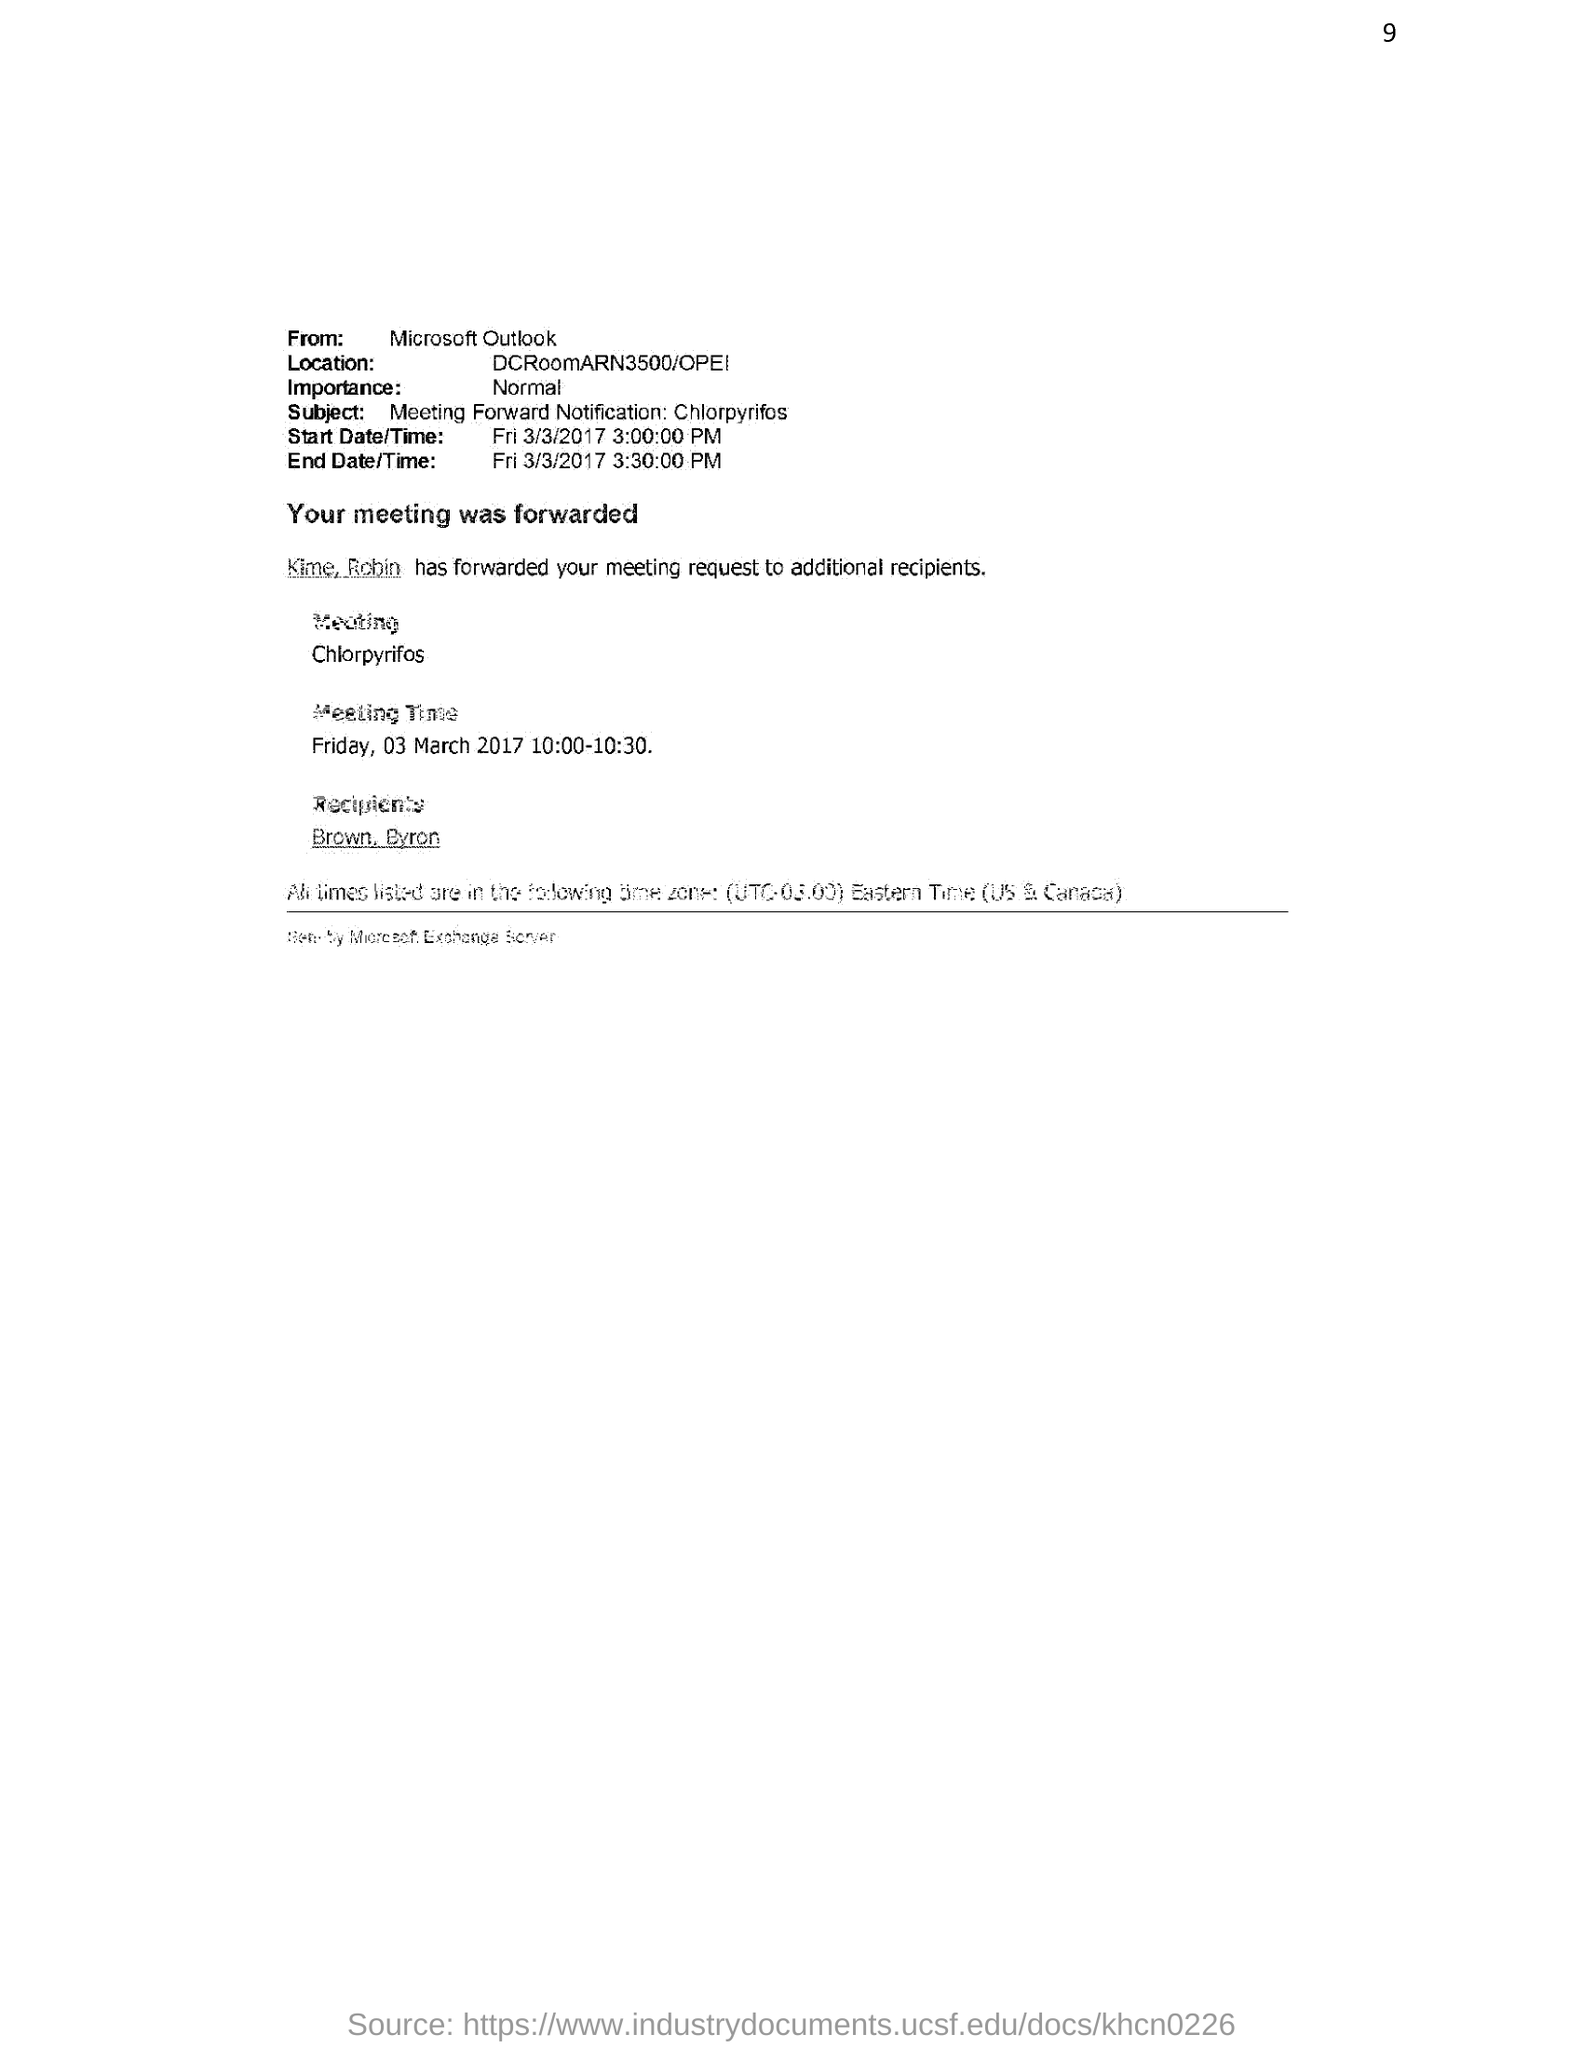Who is the sender of the email?
Provide a succinct answer. Microsoft Outlook. What is the importance of this email?
Your answer should be very brief. Normal. What is the start date/time mentioned in the email?
Give a very brief answer. Fri 3/3/2017 3:00:00 PM. What is the End date/time mentioned in the email?
Make the answer very short. Fri 3/3/2017 3:30:00 PM. What is the meeting time given in the email?
Your answer should be very brief. Friday, 03 March 2017 10:00-10:30. What is the subject of this email?
Offer a very short reply. Meeting Forward Notification: Chlorpyrifos. Who is the recipient of the meeting request?
Provide a short and direct response. Brown, Byron. 